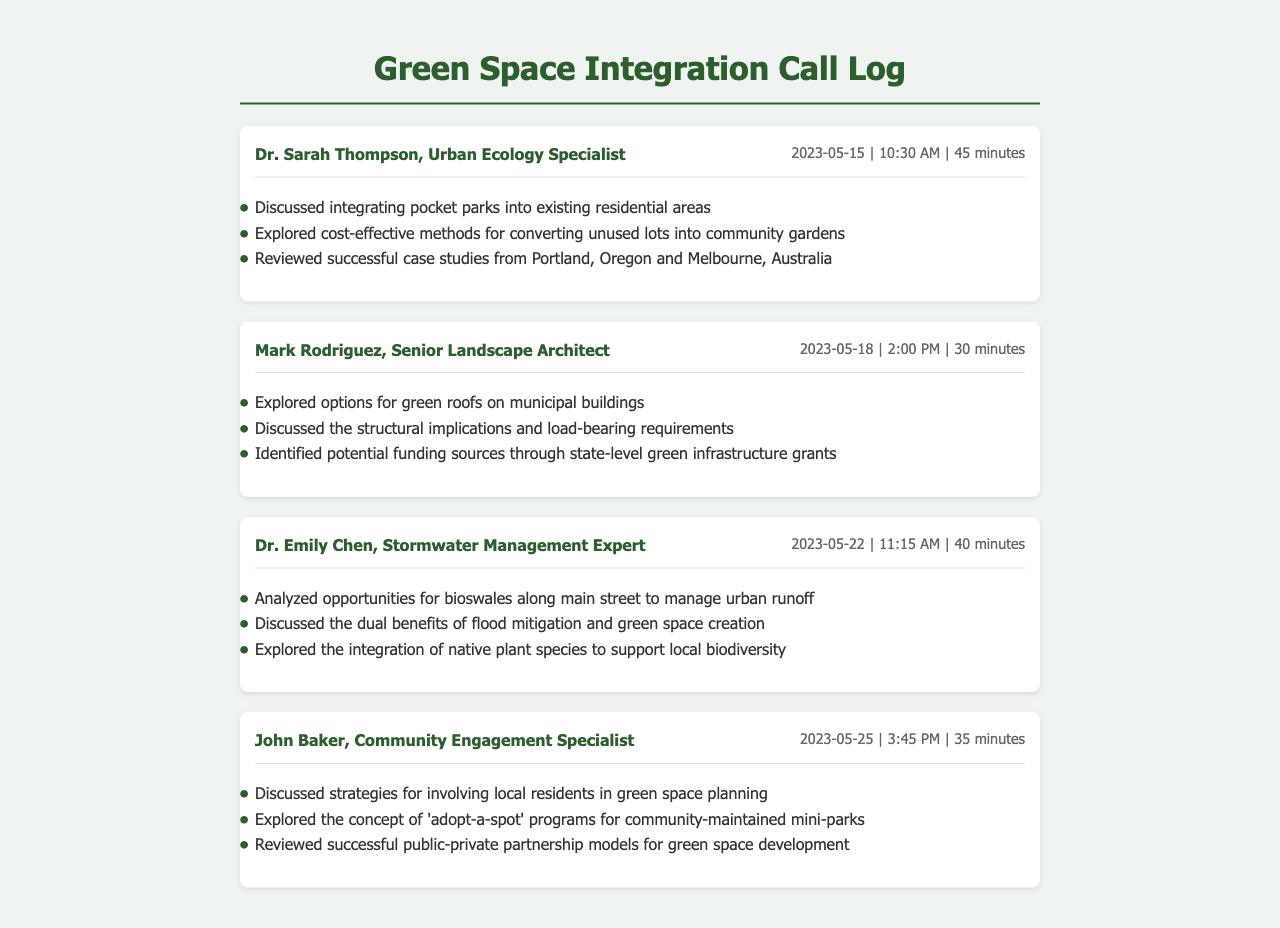What is the name of the Urban Ecology Specialist? The document lists Dr. Sarah Thompson as the Urban Ecology Specialist involved in the call log.
Answer: Dr. Sarah Thompson When was the call with Mark Rodriguez made? The document indicates that the call with Mark Rodriguez took place on May 18, 2023.
Answer: May 18, 2023 How long was the call with Dr. Emily Chen? The call duration with Dr. Emily Chen is specified as 40 minutes in the document.
Answer: 40 minutes What concept did John Baker discuss related to community involvement? The document mentions that John Baker explored the concept of 'adopt-a-spot' programs for community-maintained mini-parks.
Answer: 'adopt-a-spot' programs Which city's case studies were reviewed by Dr. Sarah Thompson? The document details that successful case studies from Portland, Oregon were one of the locations reviewed by Dr. Sarah Thompson.
Answer: Portland, Oregon What type of funding did Mark Rodriguez identify? The document states that potential funding sources were identified through state-level green infrastructure grants.
Answer: state-level green infrastructure grants Which species were discussed for integration in green spaces during Dr. Emily Chen's call? The document indicates that native plant species were mentioned for supporting local biodiversity during Dr. Emily Chen's discussion.
Answer: native plant species What strategy did John Baker recommend for green space planning? The document highlights that John Baker discussed strategies for involving local residents in green space planning.
Answer: involving local residents What is the primary focus of the calls in the document? The document outlines that the primary focus of the calls is integrating green spaces into existing infrastructure.
Answer: integrating green spaces 